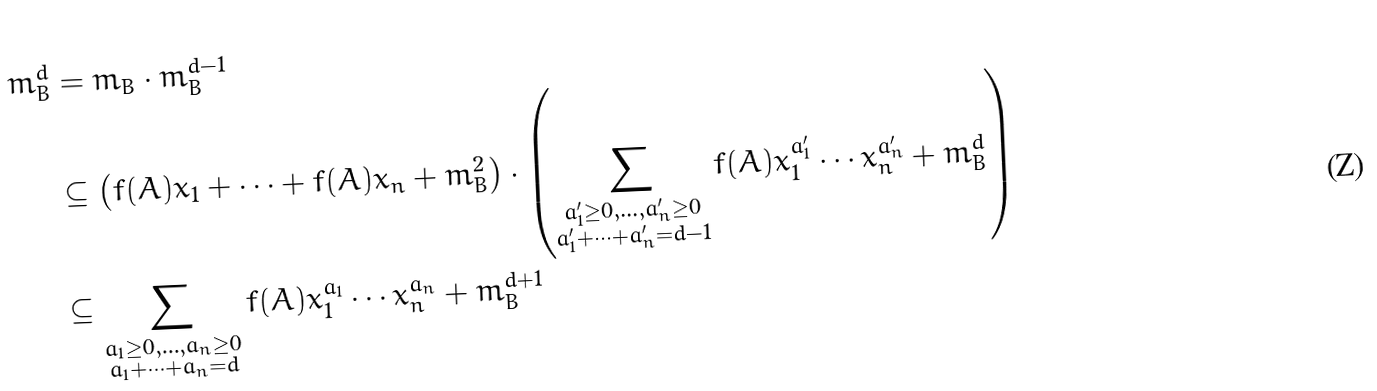<formula> <loc_0><loc_0><loc_500><loc_500>m _ { B } ^ { d } & = m _ { B } \cdot m _ { B } ^ { d - 1 } \\ & \subseteq \left ( f ( A ) x _ { 1 } + \cdots + f ( A ) x _ { n } + m _ { B } ^ { 2 } \right ) \cdot \left ( \sum _ { \substack { a ^ { \prime } _ { 1 } \geq 0 , \dots , a ^ { \prime } _ { n } \geq 0 \\ a ^ { \prime } _ { 1 } + \cdots + a ^ { \prime } _ { n } = d - 1 } } f ( A ) x _ { 1 } ^ { a ^ { \prime } _ { 1 } } \cdots x _ { n } ^ { a ^ { \prime } _ { n } } + m _ { B } ^ { d } \right ) \\ & \subseteq \sum _ { \substack { a _ { 1 } \geq 0 , \dots , a _ { n } \geq 0 \\ a _ { 1 } + \cdots + a _ { n } = d } } f ( A ) x _ { 1 } ^ { a _ { 1 } } \cdots x _ { n } ^ { a _ { n } } + m _ { B } ^ { d + 1 }</formula> 